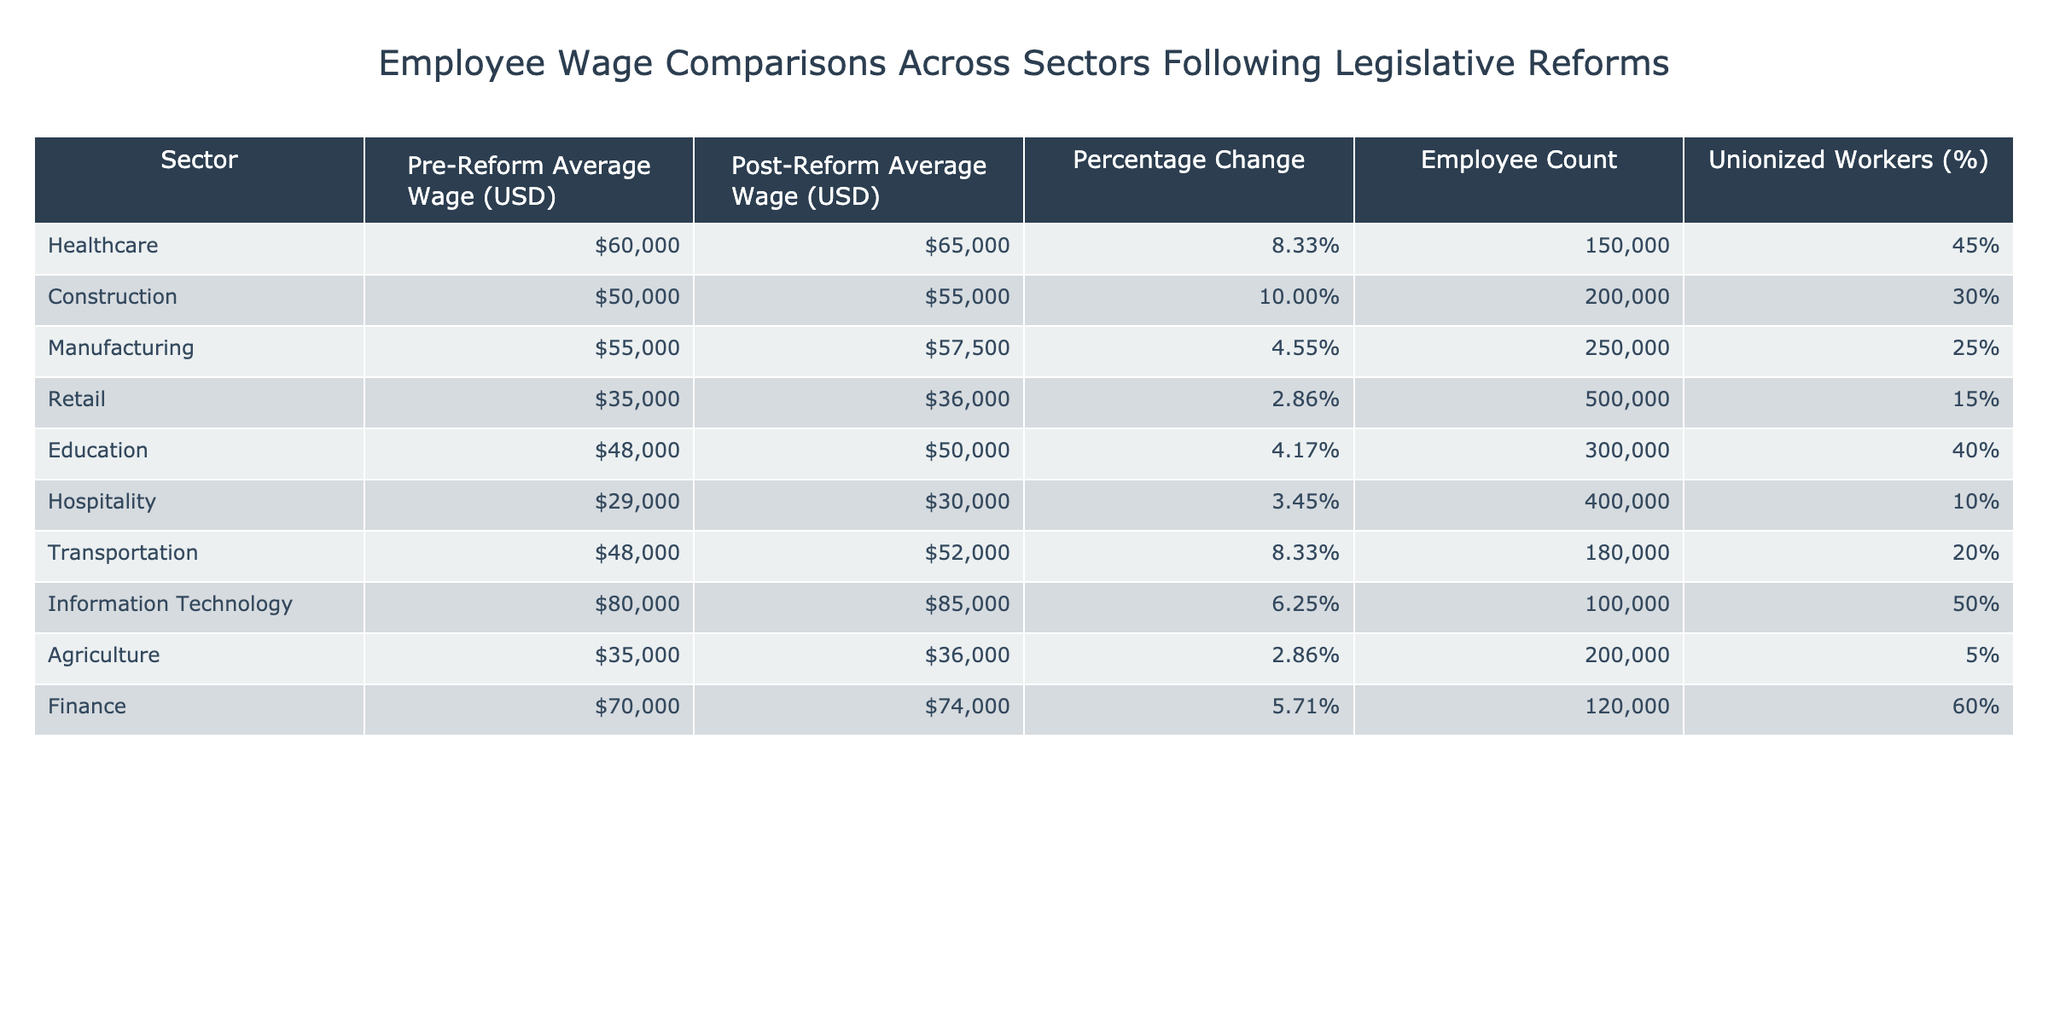What was the pre-reform average wage in the Healthcare sector? The table shows that the pre-reform average wage in the Healthcare sector is listed as $60,000.
Answer: $60,000 Which sector saw the highest percentage change in wages following the reforms? The Construction sector has the highest percentage change at 10.00%.
Answer: Construction How many employees work in the Manufacturing sector? The table indicates that there are 250,000 employees in the Manufacturing sector.
Answer: 250,000 Is the percentage of unionized workers in the Agriculture sector higher than that in the Retail sector? The table shows 5% unionized workers in Agriculture and 15% in Retail, so Agriculture has a lower percentage.
Answer: No What is the total employee count for the sectors with a pre-reform average wage above $50,000? The sectors with a pre-reform average wage above $50,000 are Healthcare, Manufacturing, Information Technology, and Finance, which have employee counts of 150,000, 250,000, 100,000, and 120,000 respectively. The total is 150,000 + 250,000 + 100,000 + 120,000 = 620,000.
Answer: 620,000 What was the increase in average wage for the Transportation sector after the reform? The pre-reform average wage in Transportation was $48,000 and it increased to $52,000 post-reform, which is an increase of $52,000 - $48,000 = $4,000.
Answer: $4,000 Which sector had the lowest post-reform average wage and what is that wage? The Hospitality sector has the lowest post-reform average wage of $30,000.
Answer: $30,000 How does the wage change in Education compare to that in Retail? The Education sector experienced a wage change of 4.17%, while Retail experienced a change of 2.86%, indicating a larger increase in Education.
Answer: Education has a higher percentage change What percentage of employees in the Finance sector are unionized compared to the Healthcare sector? The Finance sector has 60% unionized workers, while Healthcare has 45%, meaning Finance has a higher percentage of unionized workers.
Answer: Yes, Finance has a higher percentage If the average wage increase for Construction and Hospitality is combined, what percentage change do they represent? Construction had a percentage change of 10.00% and Hospitality had 3.45%. Adding these gives 10.00% + 3.45% = 13.45%.
Answer: 13.45% 